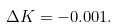<formula> <loc_0><loc_0><loc_500><loc_500>\Delta K = - 0 . 0 0 1 .</formula> 